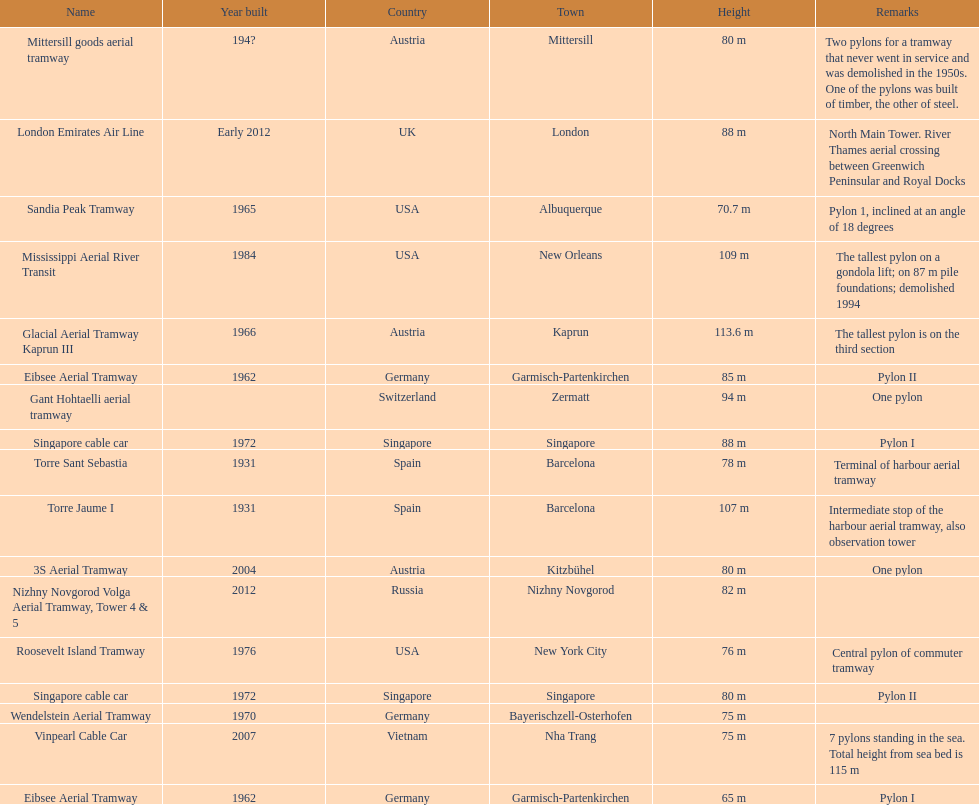What year was the last pylon in germany built? 1970. 